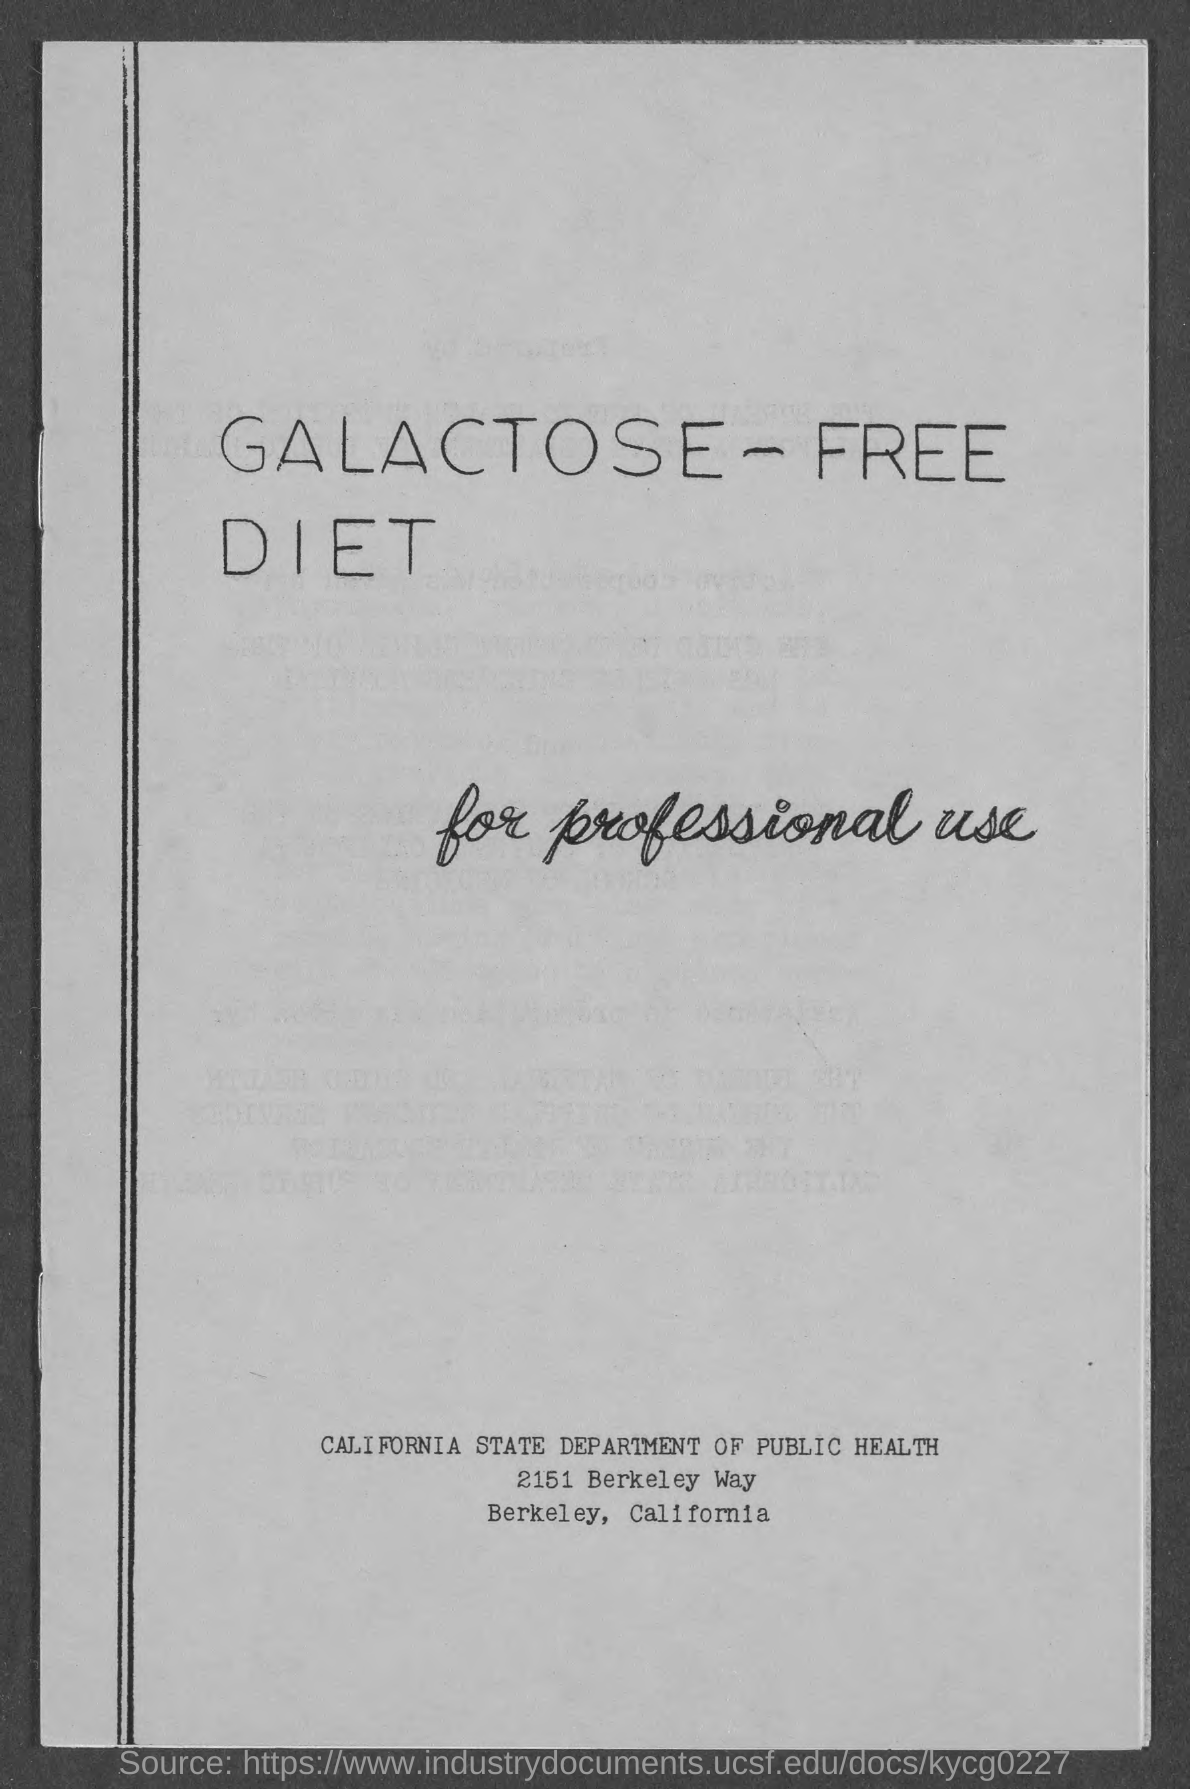Which states public health department  this document belongs to ?
Make the answer very short. California. Which department of California mentioned here in the document ?
Offer a terse response. PUBLIC HEALTH. Which state mentioned here in the document ?
Provide a short and direct response. California. What is the number given here in the document?
Offer a terse response. 2151. What is the first digit in the number written near Berkeley in this document ?
Keep it short and to the point. 2. What is the name of the Way mentioned here in the document ?
Offer a terse response. BERKELEY WAY. What is the biggest value digit in the number mentioned near the word Berkeley in this document ?
Provide a short and direct response. 5. 